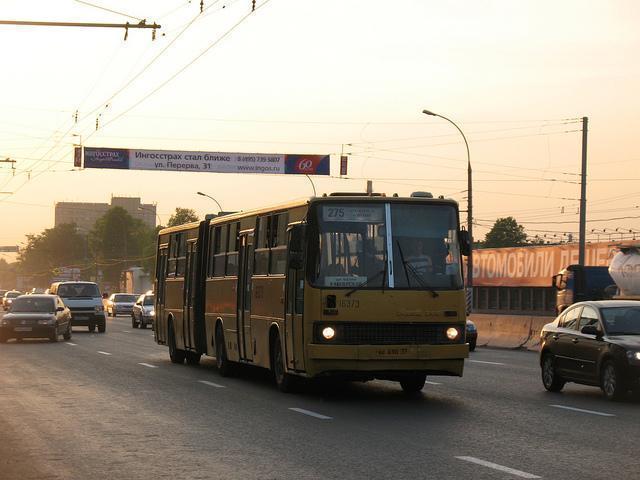What time of day does the bus drive in here?
Choose the correct response, then elucidate: 'Answer: answer
Rationale: rationale.'
Options: Noon, 1 pm, 11 am, sunset. Answer: sunset.
Rationale: The sky is beginning to darken, and the sun is not visible in the sky. all the other listed options take place at a time of day when it would be light outside. 